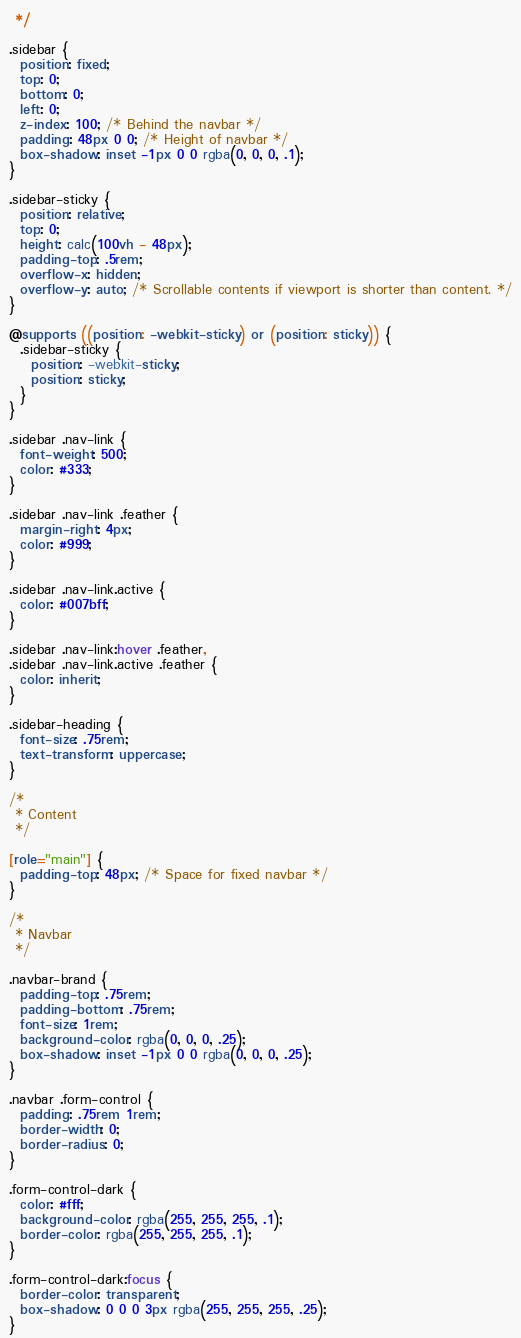Convert code to text. <code><loc_0><loc_0><loc_500><loc_500><_CSS_> */

.sidebar {
  position: fixed;
  top: 0;
  bottom: 0;
  left: 0;
  z-index: 100; /* Behind the navbar */
  padding: 48px 0 0; /* Height of navbar */
  box-shadow: inset -1px 0 0 rgba(0, 0, 0, .1);
}

.sidebar-sticky {
  position: relative;
  top: 0;
  height: calc(100vh - 48px);
  padding-top: .5rem;
  overflow-x: hidden;
  overflow-y: auto; /* Scrollable contents if viewport is shorter than content. */
}

@supports ((position: -webkit-sticky) or (position: sticky)) {
  .sidebar-sticky {
    position: -webkit-sticky;
    position: sticky;
  }
}

.sidebar .nav-link {
  font-weight: 500;
  color: #333;
}

.sidebar .nav-link .feather {
  margin-right: 4px;
  color: #999;
}

.sidebar .nav-link.active {
  color: #007bff;
}

.sidebar .nav-link:hover .feather,
.sidebar .nav-link.active .feather {
  color: inherit;
}

.sidebar-heading {
  font-size: .75rem;
  text-transform: uppercase;
}

/*
 * Content
 */

[role="main"] {
  padding-top: 48px; /* Space for fixed navbar */
}

/*
 * Navbar
 */

.navbar-brand {
  padding-top: .75rem;
  padding-bottom: .75rem;
  font-size: 1rem;
  background-color: rgba(0, 0, 0, .25);
  box-shadow: inset -1px 0 0 rgba(0, 0, 0, .25);
}

.navbar .form-control {
  padding: .75rem 1rem;
  border-width: 0;
  border-radius: 0;
}

.form-control-dark {
  color: #fff;
  background-color: rgba(255, 255, 255, .1);
  border-color: rgba(255, 255, 255, .1);
}

.form-control-dark:focus {
  border-color: transparent;
  box-shadow: 0 0 0 3px rgba(255, 255, 255, .25);
}
</code> 